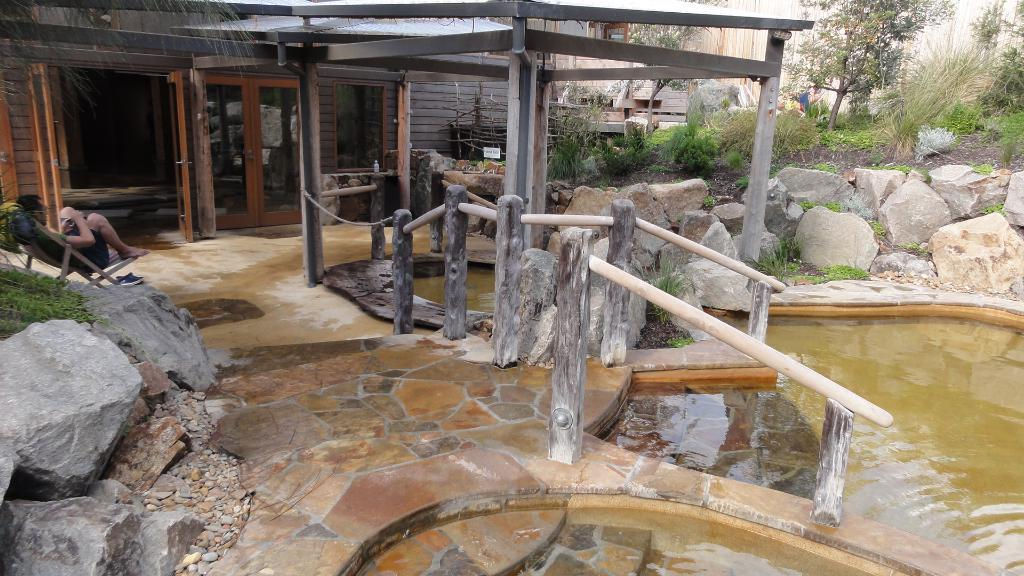What is the person in the image doing? The person is sitting on a chair in the image. What objects are present in the image that might be used for safety or guidance? Barrier poles are present in the image. What type of natural elements can be seen in the image? Rocks, shrubs, plants, and trees are visible in the image. What type of man-made structures are present in the image? There is a building in the image. What other materials can be seen in the image? Stones are visible in the image. What type of camp can be seen in the image? There is no camp present in the image. 